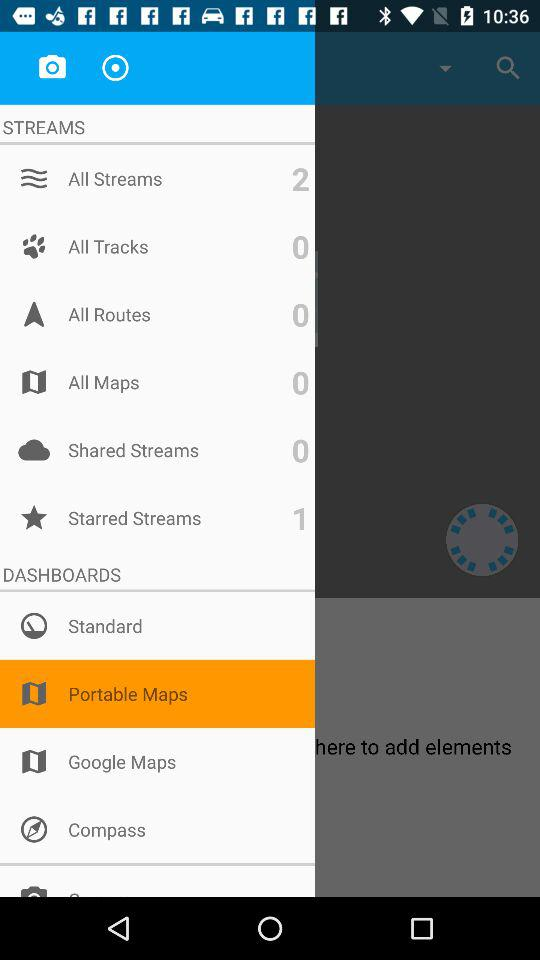How many shared streams in total are there? There are 0 shared streams. 